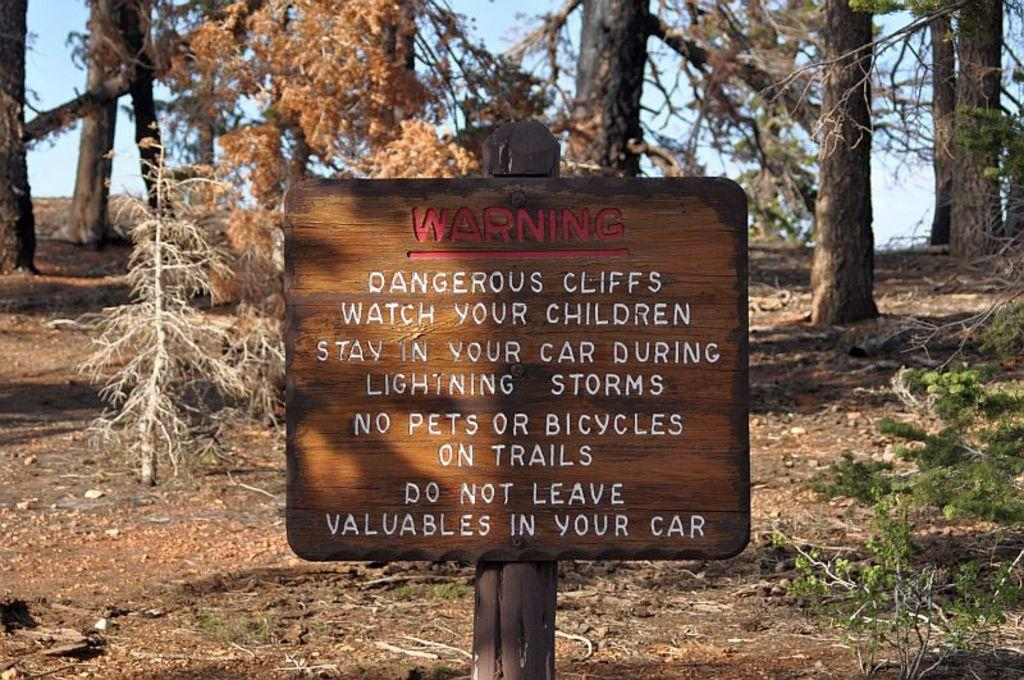What is on the wooden pole in the image? There is a board on a wooden pole in the image. What can be seen in the background of the image? There are plants, trees, and the sky visible in the background of the image. Can you see any rocks in the image? There are no rocks visible in the image. Is there a tiger present in the image? There is no tiger present in the image. What season is depicted in the image? The provided facts do not mention any specific season, so it cannot be determined from the image. 